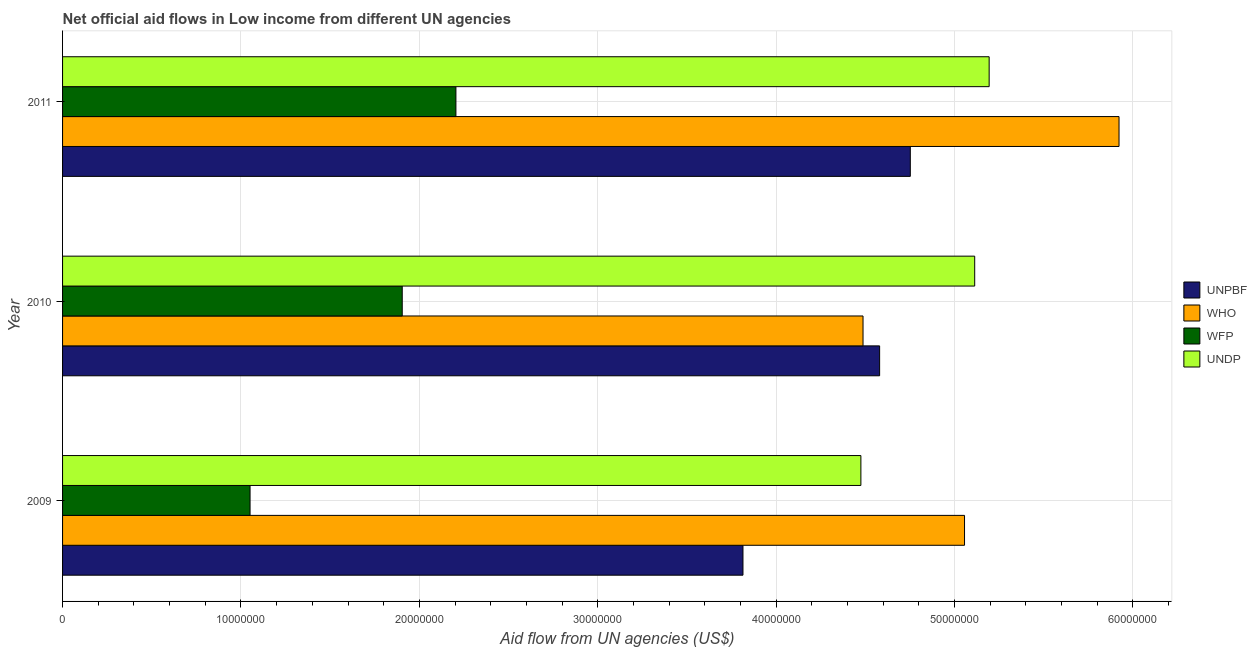How many groups of bars are there?
Your response must be concise. 3. Are the number of bars per tick equal to the number of legend labels?
Ensure brevity in your answer.  Yes. Are the number of bars on each tick of the Y-axis equal?
Offer a very short reply. Yes. How many bars are there on the 1st tick from the bottom?
Your response must be concise. 4. What is the amount of aid given by undp in 2010?
Provide a succinct answer. 5.11e+07. Across all years, what is the maximum amount of aid given by unpbf?
Your response must be concise. 4.75e+07. Across all years, what is the minimum amount of aid given by undp?
Your answer should be very brief. 4.48e+07. In which year was the amount of aid given by undp maximum?
Your answer should be compact. 2011. What is the total amount of aid given by undp in the graph?
Your answer should be compact. 1.48e+08. What is the difference between the amount of aid given by who in 2010 and that in 2011?
Provide a short and direct response. -1.44e+07. What is the difference between the amount of aid given by wfp in 2009 and the amount of aid given by undp in 2011?
Offer a terse response. -4.14e+07. What is the average amount of aid given by unpbf per year?
Ensure brevity in your answer.  4.38e+07. In the year 2011, what is the difference between the amount of aid given by undp and amount of aid given by who?
Keep it short and to the point. -7.28e+06. In how many years, is the amount of aid given by undp greater than 30000000 US$?
Offer a very short reply. 3. What is the ratio of the amount of aid given by wfp in 2010 to that in 2011?
Offer a very short reply. 0.86. Is the difference between the amount of aid given by unpbf in 2009 and 2011 greater than the difference between the amount of aid given by undp in 2009 and 2011?
Make the answer very short. No. What is the difference between the highest and the second highest amount of aid given by unpbf?
Offer a very short reply. 1.72e+06. What is the difference between the highest and the lowest amount of aid given by unpbf?
Provide a short and direct response. 9.38e+06. Is the sum of the amount of aid given by undp in 2009 and 2010 greater than the maximum amount of aid given by wfp across all years?
Keep it short and to the point. Yes. What does the 1st bar from the top in 2010 represents?
Give a very brief answer. UNDP. What does the 4th bar from the bottom in 2011 represents?
Ensure brevity in your answer.  UNDP. Is it the case that in every year, the sum of the amount of aid given by unpbf and amount of aid given by who is greater than the amount of aid given by wfp?
Offer a very short reply. Yes. Are all the bars in the graph horizontal?
Provide a short and direct response. Yes. What is the difference between two consecutive major ticks on the X-axis?
Your response must be concise. 1.00e+07. Are the values on the major ticks of X-axis written in scientific E-notation?
Provide a short and direct response. No. Does the graph contain any zero values?
Give a very brief answer. No. Does the graph contain grids?
Provide a short and direct response. Yes. What is the title of the graph?
Your answer should be very brief. Net official aid flows in Low income from different UN agencies. What is the label or title of the X-axis?
Provide a short and direct response. Aid flow from UN agencies (US$). What is the Aid flow from UN agencies (US$) of UNPBF in 2009?
Your response must be concise. 3.81e+07. What is the Aid flow from UN agencies (US$) in WHO in 2009?
Keep it short and to the point. 5.06e+07. What is the Aid flow from UN agencies (US$) in WFP in 2009?
Make the answer very short. 1.05e+07. What is the Aid flow from UN agencies (US$) in UNDP in 2009?
Make the answer very short. 4.48e+07. What is the Aid flow from UN agencies (US$) of UNPBF in 2010?
Your answer should be compact. 4.58e+07. What is the Aid flow from UN agencies (US$) in WHO in 2010?
Your response must be concise. 4.49e+07. What is the Aid flow from UN agencies (US$) in WFP in 2010?
Make the answer very short. 1.90e+07. What is the Aid flow from UN agencies (US$) of UNDP in 2010?
Your answer should be compact. 5.11e+07. What is the Aid flow from UN agencies (US$) in UNPBF in 2011?
Your answer should be compact. 4.75e+07. What is the Aid flow from UN agencies (US$) in WHO in 2011?
Your response must be concise. 5.92e+07. What is the Aid flow from UN agencies (US$) of WFP in 2011?
Keep it short and to the point. 2.20e+07. What is the Aid flow from UN agencies (US$) of UNDP in 2011?
Ensure brevity in your answer.  5.19e+07. Across all years, what is the maximum Aid flow from UN agencies (US$) of UNPBF?
Your answer should be compact. 4.75e+07. Across all years, what is the maximum Aid flow from UN agencies (US$) in WHO?
Your answer should be very brief. 5.92e+07. Across all years, what is the maximum Aid flow from UN agencies (US$) in WFP?
Give a very brief answer. 2.20e+07. Across all years, what is the maximum Aid flow from UN agencies (US$) in UNDP?
Give a very brief answer. 5.19e+07. Across all years, what is the minimum Aid flow from UN agencies (US$) in UNPBF?
Your answer should be compact. 3.81e+07. Across all years, what is the minimum Aid flow from UN agencies (US$) of WHO?
Offer a terse response. 4.49e+07. Across all years, what is the minimum Aid flow from UN agencies (US$) of WFP?
Ensure brevity in your answer.  1.05e+07. Across all years, what is the minimum Aid flow from UN agencies (US$) in UNDP?
Ensure brevity in your answer.  4.48e+07. What is the total Aid flow from UN agencies (US$) in UNPBF in the graph?
Provide a short and direct response. 1.31e+08. What is the total Aid flow from UN agencies (US$) in WHO in the graph?
Offer a very short reply. 1.55e+08. What is the total Aid flow from UN agencies (US$) in WFP in the graph?
Provide a succinct answer. 5.16e+07. What is the total Aid flow from UN agencies (US$) in UNDP in the graph?
Ensure brevity in your answer.  1.48e+08. What is the difference between the Aid flow from UN agencies (US$) in UNPBF in 2009 and that in 2010?
Keep it short and to the point. -7.66e+06. What is the difference between the Aid flow from UN agencies (US$) of WHO in 2009 and that in 2010?
Offer a terse response. 5.69e+06. What is the difference between the Aid flow from UN agencies (US$) of WFP in 2009 and that in 2010?
Offer a very short reply. -8.53e+06. What is the difference between the Aid flow from UN agencies (US$) of UNDP in 2009 and that in 2010?
Offer a terse response. -6.38e+06. What is the difference between the Aid flow from UN agencies (US$) in UNPBF in 2009 and that in 2011?
Your answer should be compact. -9.38e+06. What is the difference between the Aid flow from UN agencies (US$) in WHO in 2009 and that in 2011?
Provide a succinct answer. -8.66e+06. What is the difference between the Aid flow from UN agencies (US$) of WFP in 2009 and that in 2011?
Provide a short and direct response. -1.15e+07. What is the difference between the Aid flow from UN agencies (US$) in UNDP in 2009 and that in 2011?
Make the answer very short. -7.19e+06. What is the difference between the Aid flow from UN agencies (US$) of UNPBF in 2010 and that in 2011?
Offer a very short reply. -1.72e+06. What is the difference between the Aid flow from UN agencies (US$) in WHO in 2010 and that in 2011?
Provide a short and direct response. -1.44e+07. What is the difference between the Aid flow from UN agencies (US$) of WFP in 2010 and that in 2011?
Keep it short and to the point. -3.01e+06. What is the difference between the Aid flow from UN agencies (US$) in UNDP in 2010 and that in 2011?
Provide a succinct answer. -8.10e+05. What is the difference between the Aid flow from UN agencies (US$) in UNPBF in 2009 and the Aid flow from UN agencies (US$) in WHO in 2010?
Give a very brief answer. -6.73e+06. What is the difference between the Aid flow from UN agencies (US$) of UNPBF in 2009 and the Aid flow from UN agencies (US$) of WFP in 2010?
Keep it short and to the point. 1.91e+07. What is the difference between the Aid flow from UN agencies (US$) of UNPBF in 2009 and the Aid flow from UN agencies (US$) of UNDP in 2010?
Your answer should be very brief. -1.30e+07. What is the difference between the Aid flow from UN agencies (US$) of WHO in 2009 and the Aid flow from UN agencies (US$) of WFP in 2010?
Give a very brief answer. 3.15e+07. What is the difference between the Aid flow from UN agencies (US$) of WHO in 2009 and the Aid flow from UN agencies (US$) of UNDP in 2010?
Provide a short and direct response. -5.70e+05. What is the difference between the Aid flow from UN agencies (US$) in WFP in 2009 and the Aid flow from UN agencies (US$) in UNDP in 2010?
Offer a terse response. -4.06e+07. What is the difference between the Aid flow from UN agencies (US$) in UNPBF in 2009 and the Aid flow from UN agencies (US$) in WHO in 2011?
Provide a succinct answer. -2.11e+07. What is the difference between the Aid flow from UN agencies (US$) in UNPBF in 2009 and the Aid flow from UN agencies (US$) in WFP in 2011?
Provide a succinct answer. 1.61e+07. What is the difference between the Aid flow from UN agencies (US$) in UNPBF in 2009 and the Aid flow from UN agencies (US$) in UNDP in 2011?
Your answer should be very brief. -1.38e+07. What is the difference between the Aid flow from UN agencies (US$) of WHO in 2009 and the Aid flow from UN agencies (US$) of WFP in 2011?
Give a very brief answer. 2.85e+07. What is the difference between the Aid flow from UN agencies (US$) of WHO in 2009 and the Aid flow from UN agencies (US$) of UNDP in 2011?
Provide a succinct answer. -1.38e+06. What is the difference between the Aid flow from UN agencies (US$) in WFP in 2009 and the Aid flow from UN agencies (US$) in UNDP in 2011?
Give a very brief answer. -4.14e+07. What is the difference between the Aid flow from UN agencies (US$) in UNPBF in 2010 and the Aid flow from UN agencies (US$) in WHO in 2011?
Ensure brevity in your answer.  -1.34e+07. What is the difference between the Aid flow from UN agencies (US$) in UNPBF in 2010 and the Aid flow from UN agencies (US$) in WFP in 2011?
Your answer should be compact. 2.38e+07. What is the difference between the Aid flow from UN agencies (US$) of UNPBF in 2010 and the Aid flow from UN agencies (US$) of UNDP in 2011?
Keep it short and to the point. -6.14e+06. What is the difference between the Aid flow from UN agencies (US$) in WHO in 2010 and the Aid flow from UN agencies (US$) in WFP in 2011?
Your answer should be compact. 2.28e+07. What is the difference between the Aid flow from UN agencies (US$) of WHO in 2010 and the Aid flow from UN agencies (US$) of UNDP in 2011?
Offer a terse response. -7.07e+06. What is the difference between the Aid flow from UN agencies (US$) in WFP in 2010 and the Aid flow from UN agencies (US$) in UNDP in 2011?
Make the answer very short. -3.29e+07. What is the average Aid flow from UN agencies (US$) of UNPBF per year?
Your answer should be very brief. 4.38e+07. What is the average Aid flow from UN agencies (US$) of WHO per year?
Your answer should be very brief. 5.16e+07. What is the average Aid flow from UN agencies (US$) of WFP per year?
Ensure brevity in your answer.  1.72e+07. What is the average Aid flow from UN agencies (US$) in UNDP per year?
Offer a very short reply. 4.93e+07. In the year 2009, what is the difference between the Aid flow from UN agencies (US$) in UNPBF and Aid flow from UN agencies (US$) in WHO?
Make the answer very short. -1.24e+07. In the year 2009, what is the difference between the Aid flow from UN agencies (US$) in UNPBF and Aid flow from UN agencies (US$) in WFP?
Make the answer very short. 2.76e+07. In the year 2009, what is the difference between the Aid flow from UN agencies (US$) in UNPBF and Aid flow from UN agencies (US$) in UNDP?
Provide a succinct answer. -6.61e+06. In the year 2009, what is the difference between the Aid flow from UN agencies (US$) in WHO and Aid flow from UN agencies (US$) in WFP?
Keep it short and to the point. 4.00e+07. In the year 2009, what is the difference between the Aid flow from UN agencies (US$) of WHO and Aid flow from UN agencies (US$) of UNDP?
Your answer should be compact. 5.81e+06. In the year 2009, what is the difference between the Aid flow from UN agencies (US$) in WFP and Aid flow from UN agencies (US$) in UNDP?
Offer a very short reply. -3.42e+07. In the year 2010, what is the difference between the Aid flow from UN agencies (US$) in UNPBF and Aid flow from UN agencies (US$) in WHO?
Provide a short and direct response. 9.30e+05. In the year 2010, what is the difference between the Aid flow from UN agencies (US$) in UNPBF and Aid flow from UN agencies (US$) in WFP?
Provide a short and direct response. 2.68e+07. In the year 2010, what is the difference between the Aid flow from UN agencies (US$) of UNPBF and Aid flow from UN agencies (US$) of UNDP?
Keep it short and to the point. -5.33e+06. In the year 2010, what is the difference between the Aid flow from UN agencies (US$) in WHO and Aid flow from UN agencies (US$) in WFP?
Ensure brevity in your answer.  2.58e+07. In the year 2010, what is the difference between the Aid flow from UN agencies (US$) of WHO and Aid flow from UN agencies (US$) of UNDP?
Your answer should be very brief. -6.26e+06. In the year 2010, what is the difference between the Aid flow from UN agencies (US$) of WFP and Aid flow from UN agencies (US$) of UNDP?
Offer a very short reply. -3.21e+07. In the year 2011, what is the difference between the Aid flow from UN agencies (US$) in UNPBF and Aid flow from UN agencies (US$) in WHO?
Provide a succinct answer. -1.17e+07. In the year 2011, what is the difference between the Aid flow from UN agencies (US$) in UNPBF and Aid flow from UN agencies (US$) in WFP?
Make the answer very short. 2.55e+07. In the year 2011, what is the difference between the Aid flow from UN agencies (US$) in UNPBF and Aid flow from UN agencies (US$) in UNDP?
Keep it short and to the point. -4.42e+06. In the year 2011, what is the difference between the Aid flow from UN agencies (US$) of WHO and Aid flow from UN agencies (US$) of WFP?
Ensure brevity in your answer.  3.72e+07. In the year 2011, what is the difference between the Aid flow from UN agencies (US$) in WHO and Aid flow from UN agencies (US$) in UNDP?
Your answer should be very brief. 7.28e+06. In the year 2011, what is the difference between the Aid flow from UN agencies (US$) in WFP and Aid flow from UN agencies (US$) in UNDP?
Your answer should be compact. -2.99e+07. What is the ratio of the Aid flow from UN agencies (US$) in UNPBF in 2009 to that in 2010?
Give a very brief answer. 0.83. What is the ratio of the Aid flow from UN agencies (US$) of WHO in 2009 to that in 2010?
Make the answer very short. 1.13. What is the ratio of the Aid flow from UN agencies (US$) in WFP in 2009 to that in 2010?
Keep it short and to the point. 0.55. What is the ratio of the Aid flow from UN agencies (US$) of UNDP in 2009 to that in 2010?
Your answer should be compact. 0.88. What is the ratio of the Aid flow from UN agencies (US$) of UNPBF in 2009 to that in 2011?
Provide a short and direct response. 0.8. What is the ratio of the Aid flow from UN agencies (US$) in WHO in 2009 to that in 2011?
Offer a terse response. 0.85. What is the ratio of the Aid flow from UN agencies (US$) of WFP in 2009 to that in 2011?
Give a very brief answer. 0.48. What is the ratio of the Aid flow from UN agencies (US$) in UNDP in 2009 to that in 2011?
Provide a short and direct response. 0.86. What is the ratio of the Aid flow from UN agencies (US$) of UNPBF in 2010 to that in 2011?
Offer a very short reply. 0.96. What is the ratio of the Aid flow from UN agencies (US$) of WHO in 2010 to that in 2011?
Offer a very short reply. 0.76. What is the ratio of the Aid flow from UN agencies (US$) of WFP in 2010 to that in 2011?
Keep it short and to the point. 0.86. What is the ratio of the Aid flow from UN agencies (US$) of UNDP in 2010 to that in 2011?
Give a very brief answer. 0.98. What is the difference between the highest and the second highest Aid flow from UN agencies (US$) of UNPBF?
Make the answer very short. 1.72e+06. What is the difference between the highest and the second highest Aid flow from UN agencies (US$) in WHO?
Give a very brief answer. 8.66e+06. What is the difference between the highest and the second highest Aid flow from UN agencies (US$) of WFP?
Your response must be concise. 3.01e+06. What is the difference between the highest and the second highest Aid flow from UN agencies (US$) of UNDP?
Your answer should be very brief. 8.10e+05. What is the difference between the highest and the lowest Aid flow from UN agencies (US$) in UNPBF?
Your response must be concise. 9.38e+06. What is the difference between the highest and the lowest Aid flow from UN agencies (US$) in WHO?
Your answer should be very brief. 1.44e+07. What is the difference between the highest and the lowest Aid flow from UN agencies (US$) in WFP?
Give a very brief answer. 1.15e+07. What is the difference between the highest and the lowest Aid flow from UN agencies (US$) in UNDP?
Provide a short and direct response. 7.19e+06. 